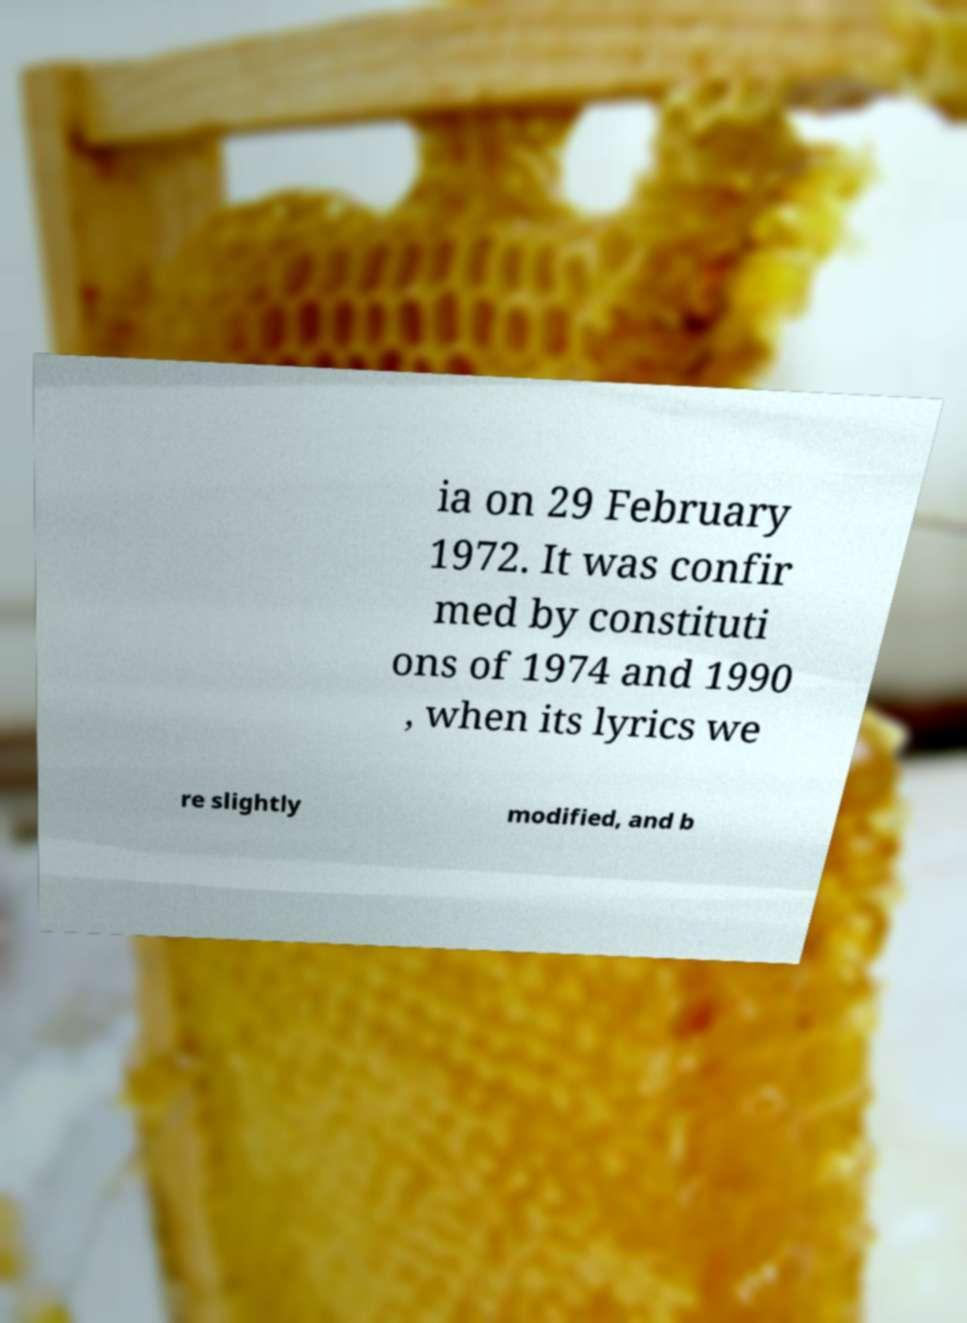Could you assist in decoding the text presented in this image and type it out clearly? ia on 29 February 1972. It was confir med by constituti ons of 1974 and 1990 , when its lyrics we re slightly modified, and b 